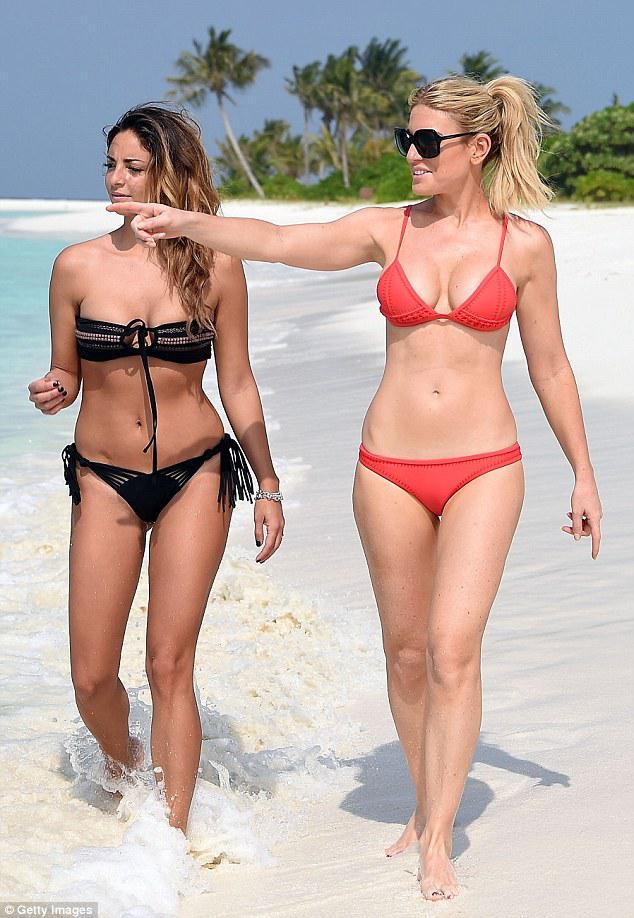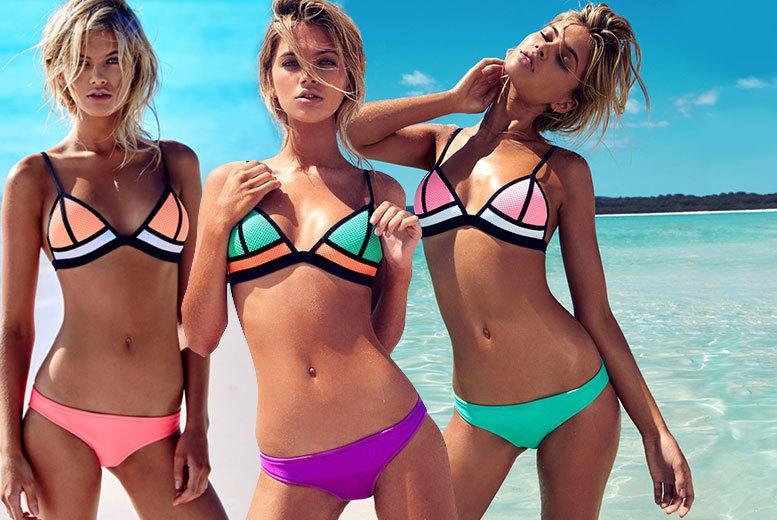The first image is the image on the left, the second image is the image on the right. For the images shown, is this caption "An image shows three rear-facing models, standing in front of water." true? Answer yes or no. No. The first image is the image on the left, the second image is the image on the right. For the images shown, is this caption "In one image, the backsides of three women dressed in bikinis are visible" true? Answer yes or no. No. 